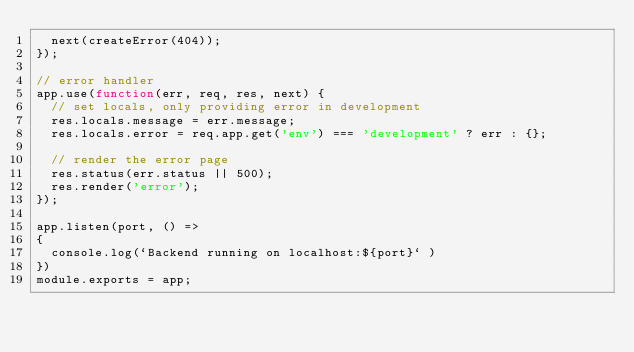<code> <loc_0><loc_0><loc_500><loc_500><_JavaScript_>  next(createError(404));
});

// error handler
app.use(function(err, req, res, next) {
  // set locals, only providing error in development
  res.locals.message = err.message;
  res.locals.error = req.app.get('env') === 'development' ? err : {};

  // render the error page
  res.status(err.status || 500);
  res.render('error');
});

app.listen(port, () =>
{
  console.log(`Backend running on localhost:${port}` )
})
module.exports = app;
</code> 